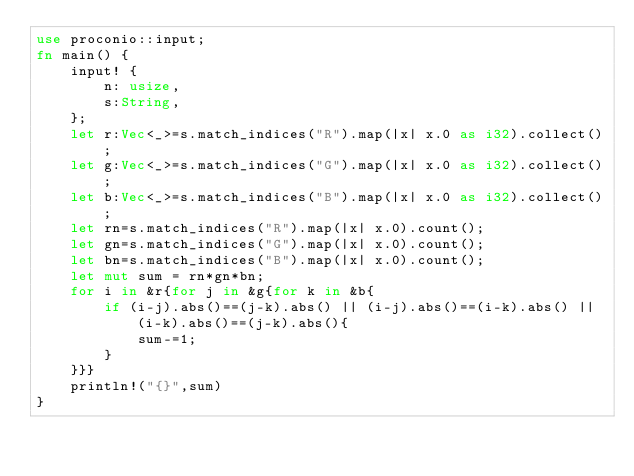<code> <loc_0><loc_0><loc_500><loc_500><_Rust_>use proconio::input;
fn main() {
    input! {
        n: usize,
        s:String,
    };
    let r:Vec<_>=s.match_indices("R").map(|x| x.0 as i32).collect();
    let g:Vec<_>=s.match_indices("G").map(|x| x.0 as i32).collect();
    let b:Vec<_>=s.match_indices("B").map(|x| x.0 as i32).collect();
    let rn=s.match_indices("R").map(|x| x.0).count();
    let gn=s.match_indices("G").map(|x| x.0).count();
    let bn=s.match_indices("B").map(|x| x.0).count();
    let mut sum = rn*gn*bn;
    for i in &r{for j in &g{for k in &b{
        if (i-j).abs()==(j-k).abs() || (i-j).abs()==(i-k).abs() || (i-k).abs()==(j-k).abs(){
            sum-=1;
        }
    }}}
    println!("{}",sum)
}
</code> 